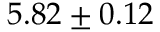Convert formula to latex. <formula><loc_0><loc_0><loc_500><loc_500>5 . 8 2 \pm 0 . 1 2</formula> 